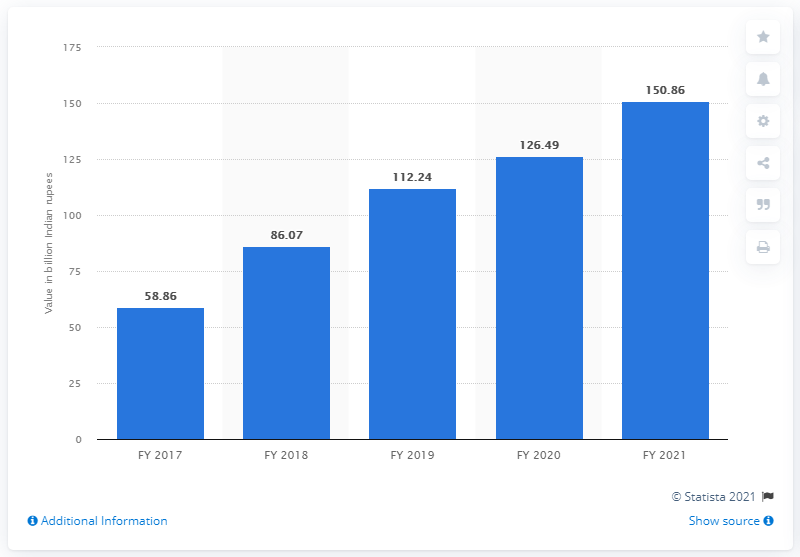Give some essential details in this illustration. The value of gross non-performing assets at HDFC Bank Limited in Indian rupees in 2021 was 150.86. In 2021, the value of NPAs (Non-Performing Assets) filed by HDFC Bank Limited was 126.49 crores. In 2021, the gross non-performing asset value of Indian private banks was approximately 126.49 Indian rupees. 